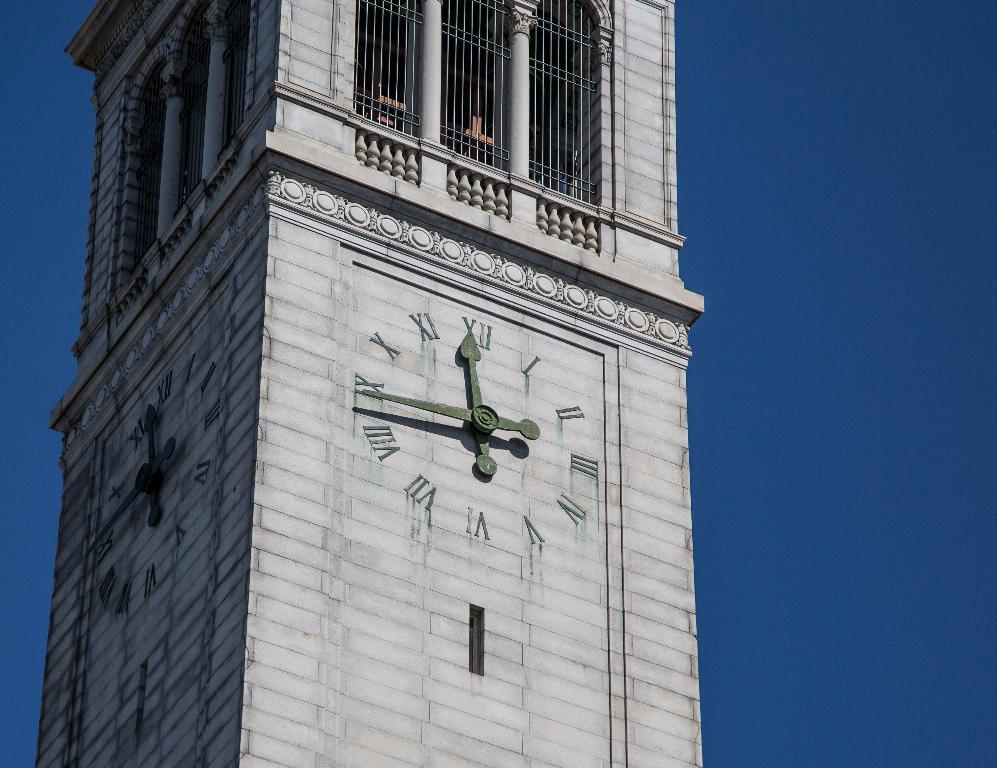Can you describe this image briefly? In the image we can see a tower, fence, clock and a blue sky. 